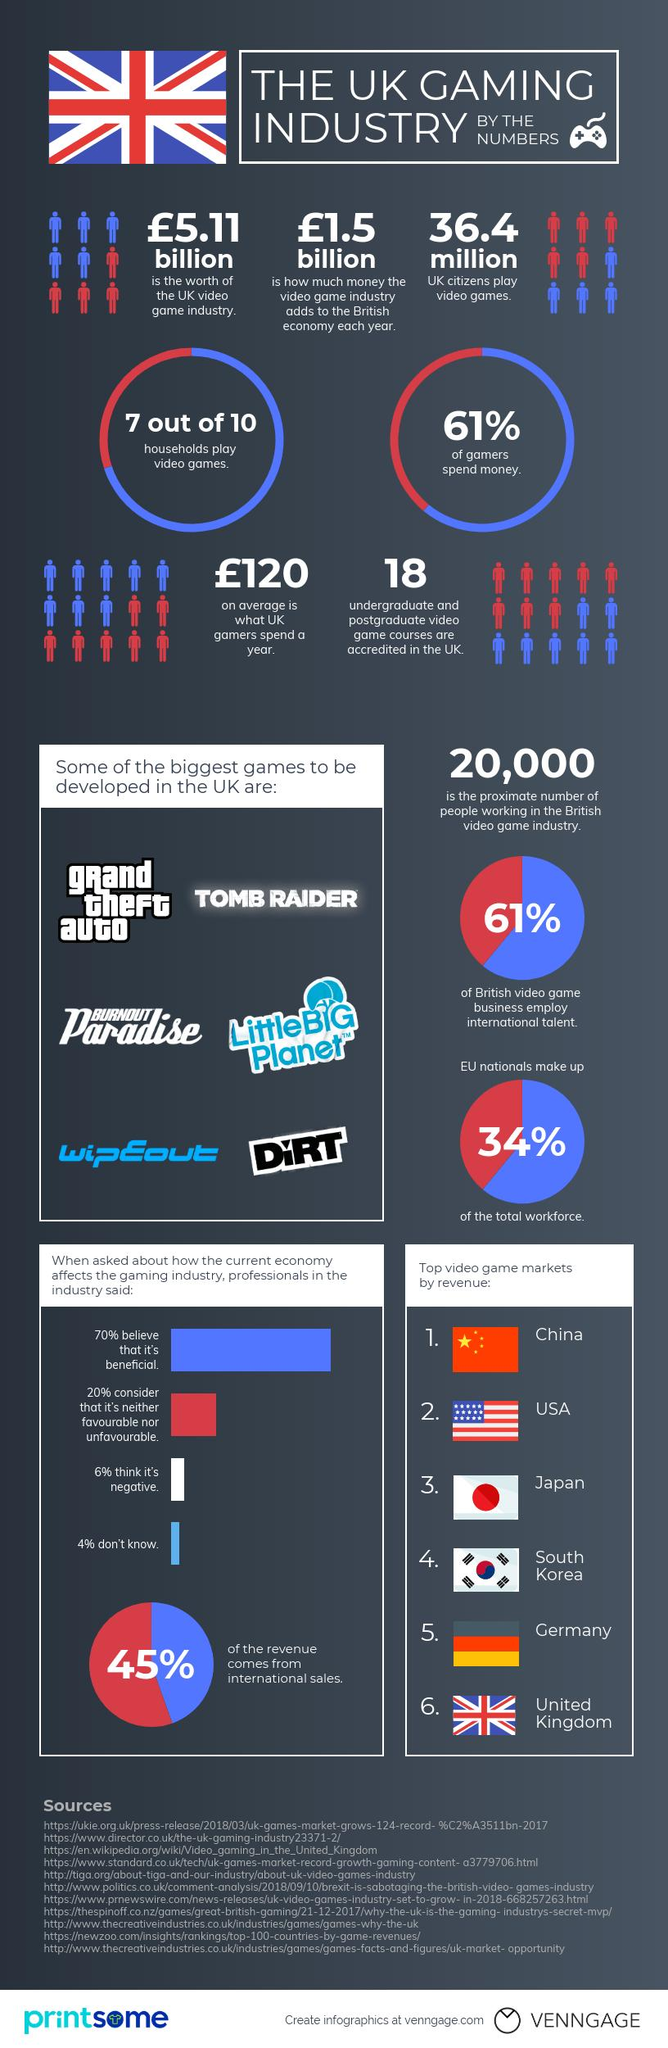Outline some significant characteristics in this image. According to recent data, a staggering 36.4 million UK citizens engage in video gaming. There are 18 accredited undergraduate and postgraduate game courses in the UK. The UK video game industry is valued at 5.11 billion pounds. According to recent data, China is the country with the highest video game revenue. 